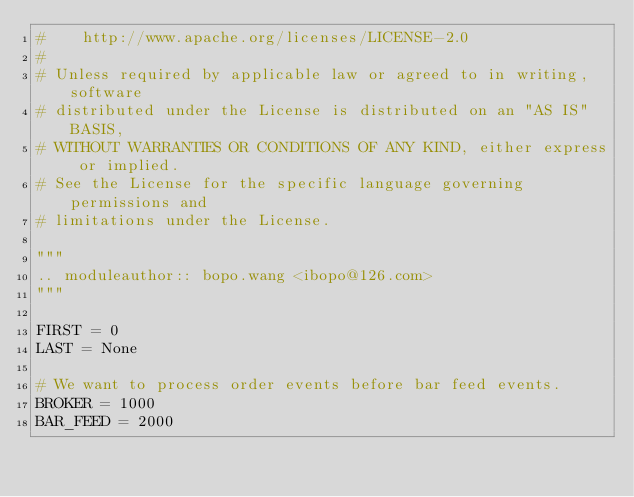Convert code to text. <code><loc_0><loc_0><loc_500><loc_500><_Python_>#    http://www.apache.org/licenses/LICENSE-2.0
#
# Unless required by applicable law or agreed to in writing, software
# distributed under the License is distributed on an "AS IS" BASIS,
# WITHOUT WARRANTIES OR CONDITIONS OF ANY KIND, either express or implied.
# See the License for the specific language governing permissions and
# limitations under the License.

"""
.. moduleauthor:: bopo.wang <ibopo@126.com>
"""

FIRST = 0
LAST = None

# We want to process order events before bar feed events.
BROKER = 1000
BAR_FEED = 2000
</code> 